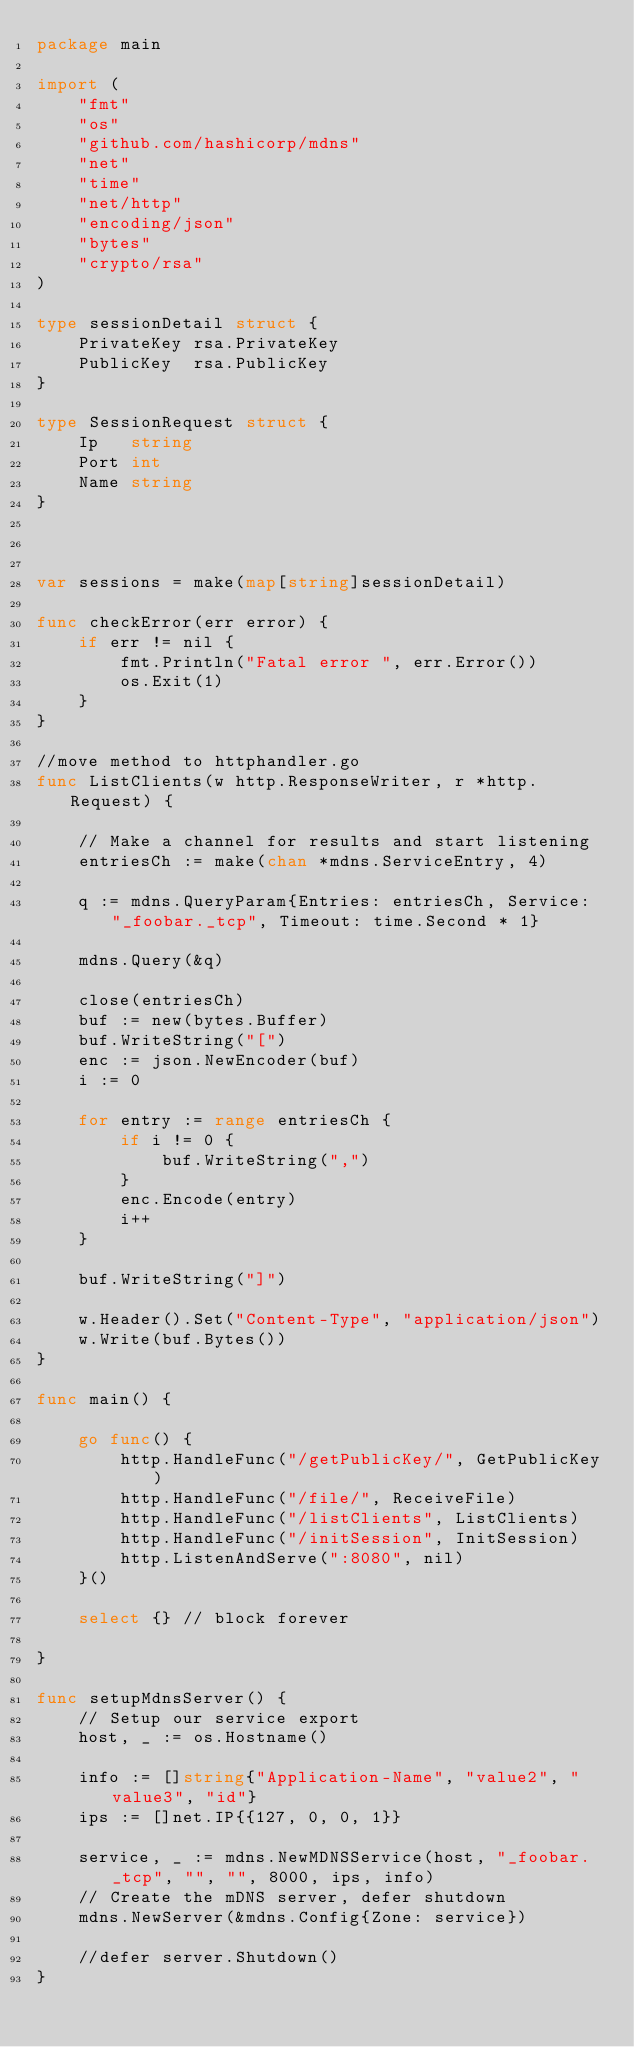<code> <loc_0><loc_0><loc_500><loc_500><_Go_>package main

import (
	"fmt"
	"os"
	"github.com/hashicorp/mdns"
	"net"
	"time"
	"net/http"
	"encoding/json"
	"bytes"
	"crypto/rsa"
)

type sessionDetail struct {
	PrivateKey rsa.PrivateKey
	PublicKey  rsa.PublicKey
}

type SessionRequest struct {
	Ip   string
	Port int
	Name string
}



var sessions = make(map[string]sessionDetail)

func checkError(err error) {
	if err != nil {
		fmt.Println("Fatal error ", err.Error())
		os.Exit(1)
	}
}

//move method to httphandler.go
func ListClients(w http.ResponseWriter, r *http.Request) {

	// Make a channel for results and start listening
	entriesCh := make(chan *mdns.ServiceEntry, 4)

	q := mdns.QueryParam{Entries: entriesCh, Service: "_foobar._tcp", Timeout: time.Second * 1}

	mdns.Query(&q)

	close(entriesCh)
	buf := new(bytes.Buffer)
	buf.WriteString("[")
	enc := json.NewEncoder(buf)
	i := 0

	for entry := range entriesCh {
		if i != 0 {
			buf.WriteString(",")
		}
		enc.Encode(entry)
		i++
	}

	buf.WriteString("]")

	w.Header().Set("Content-Type", "application/json")
	w.Write(buf.Bytes())
}

func main() {

	go func() {
		http.HandleFunc("/getPublicKey/", GetPublicKey)
		http.HandleFunc("/file/", ReceiveFile)
		http.HandleFunc("/listClients", ListClients)
		http.HandleFunc("/initSession", InitSession)
		http.ListenAndServe(":8080", nil)
	}()

	select {} // block forever

}

func setupMdnsServer() {
	// Setup our service export
	host, _ := os.Hostname()

	info := []string{"Application-Name", "value2", "value3", "id"}
	ips := []net.IP{{127, 0, 0, 1}}

	service, _ := mdns.NewMDNSService(host, "_foobar._tcp", "", "", 8000, ips, info)
	// Create the mDNS server, defer shutdown
	mdns.NewServer(&mdns.Config{Zone: service})

	//defer server.Shutdown()
}
</code> 